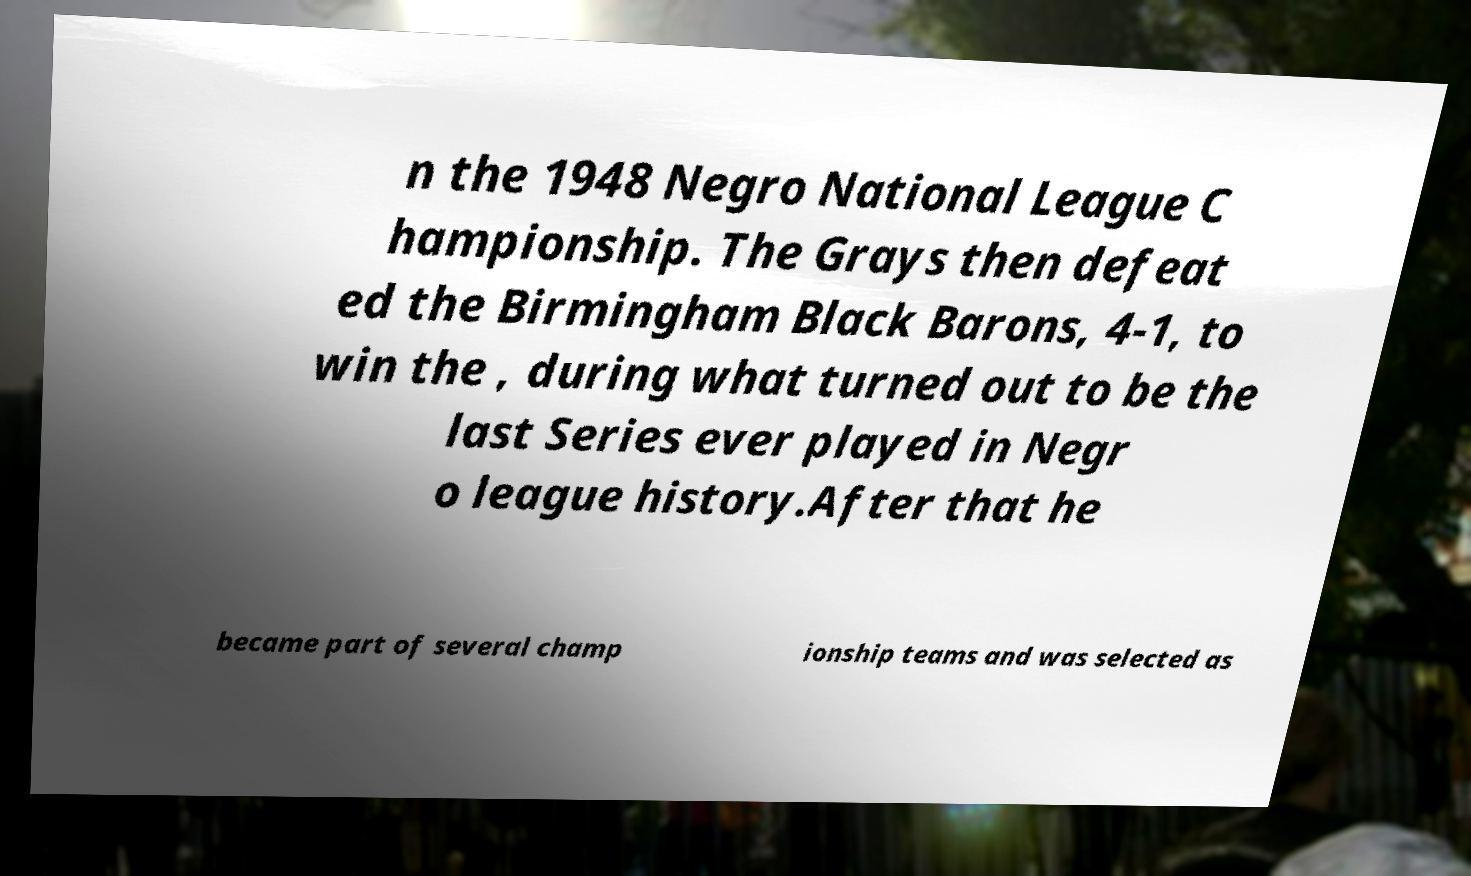Could you extract and type out the text from this image? n the 1948 Negro National League C hampionship. The Grays then defeat ed the Birmingham Black Barons, 4-1, to win the , during what turned out to be the last Series ever played in Negr o league history.After that he became part of several champ ionship teams and was selected as 